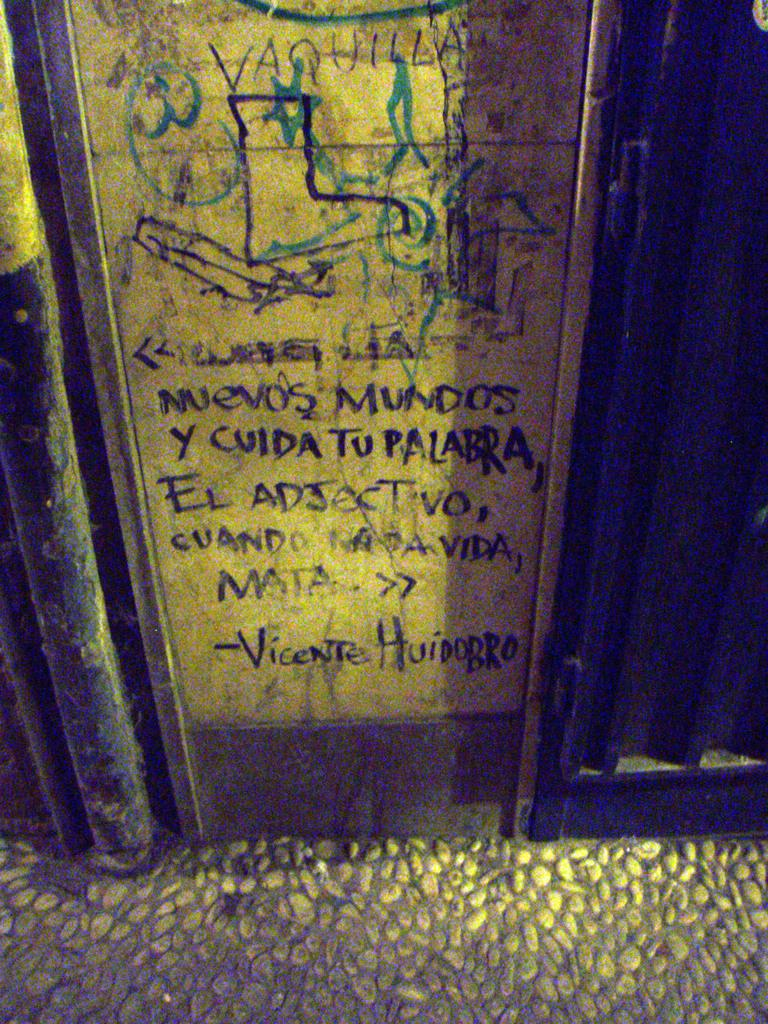Provide a one-sentence caption for the provided image. A sign in spanish referencing Vicente Huidobro reads "Nuevos Mundos y cuida tu palabra, El Adjectivo, cuando nada vida, matar. 